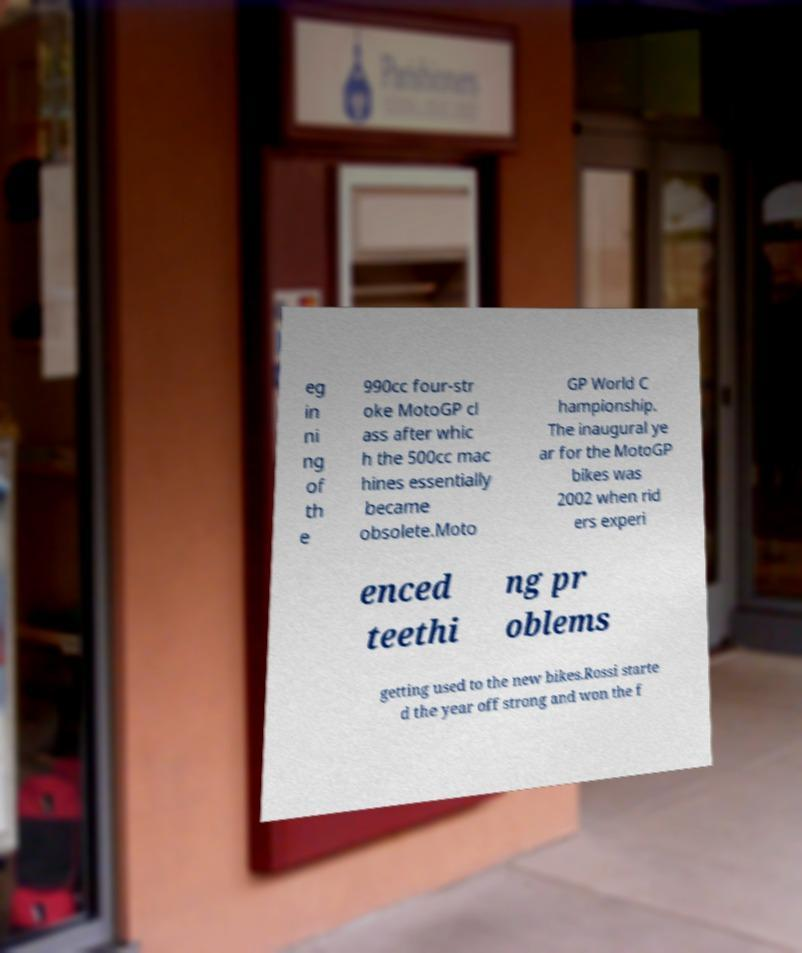Please identify and transcribe the text found in this image. eg in ni ng of th e 990cc four-str oke MotoGP cl ass after whic h the 500cc mac hines essentially became obsolete.Moto GP World C hampionship. The inaugural ye ar for the MotoGP bikes was 2002 when rid ers experi enced teethi ng pr oblems getting used to the new bikes.Rossi starte d the year off strong and won the f 